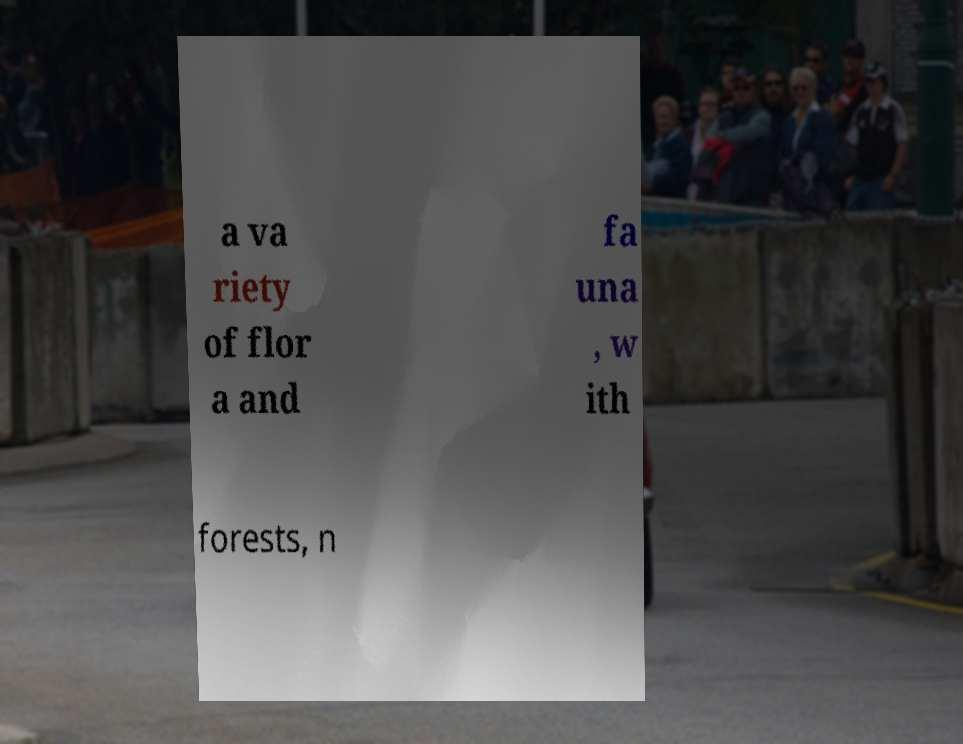What messages or text are displayed in this image? I need them in a readable, typed format. a va riety of flor a and fa una , w ith forests, n 